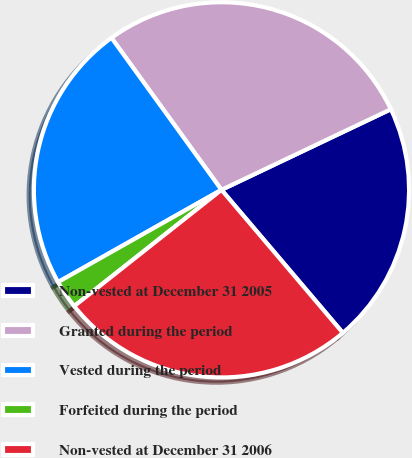Convert chart. <chart><loc_0><loc_0><loc_500><loc_500><pie_chart><fcel>Non-vested at December 31 2005<fcel>Granted during the period<fcel>Vested during the period<fcel>Forfeited during the period<fcel>Non-vested at December 31 2006<nl><fcel>20.87%<fcel>27.9%<fcel>23.21%<fcel>2.46%<fcel>25.56%<nl></chart> 